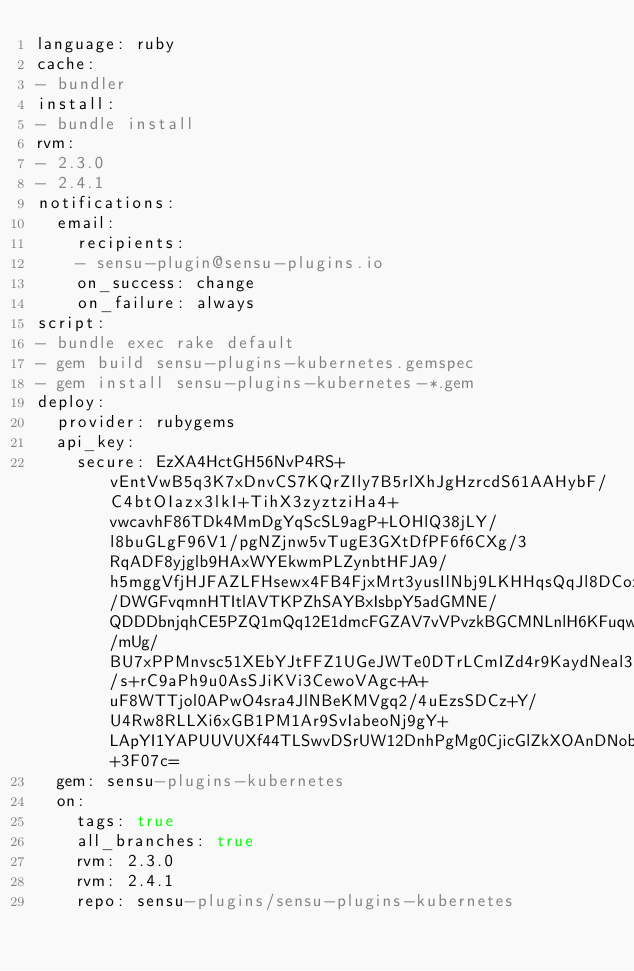<code> <loc_0><loc_0><loc_500><loc_500><_YAML_>language: ruby
cache:
- bundler
install:
- bundle install
rvm:
- 2.3.0
- 2.4.1
notifications:
  email:
    recipients:
    - sensu-plugin@sensu-plugins.io
    on_success: change
    on_failure: always
script:
- bundle exec rake default
- gem build sensu-plugins-kubernetes.gemspec
- gem install sensu-plugins-kubernetes-*.gem
deploy:
  provider: rubygems
  api_key:
    secure: EzXA4HctGH56NvP4RS+vEntVwB5q3K7xDnvCS7KQrZIly7B5rlXhJgHzrcdS61AAHybF/C4btOIazx3lkI+TihX3zyztziHa4+vwcavhF86TDk4MmDgYqScSL9agP+LOHlQ38jLY/l8buGLgF96V1/pgNZjnw5vTugE3GXtDfPF6f6CXg/3RqADF8yjglb9HAxWYEkwmPLZynbtHFJA9/h5mggVfjHJFAZLFHsewx4FB4FjxMrt3yusIlNbj9LKHHqsQqJl8DCoxGhiQmysSLS3NoN7vVhi3UA4TdHArtSZgRmsZKhsJDGcgM/DWGFvqmnHTItlAVTKPZhSAYBxIsbpY5adGMNE/QDDDbnjqhCE5PZQ1mQq12E1dmcFGZAV7vVPvzkBGCMNLnlH6KFuqw/mUg/BU7xPPMnvsc51XEbYJtFFZ1UGeJWTe0DTrLCmIZd4r9KaydNeal35iu/s+rC9aPh9u0AsSJiKVi3CewoVAgc+A+uF8WTTjol0APwO4sra4JlNBeKMVgq2/4uEzsSDCz+Y/U4Rw8RLLXi6xGB1PM1Ar9SvIabeoNj9gY+LApYI1YAPUUVUXf44TLSwvDSrUW12DnhPgMg0CjicGlZkXOAnDNob8b8bU8YUP7wN8eOwt0J63hhn40G7XCA5WCpNm0W7qbLlV8sUBb+3F07c=
  gem: sensu-plugins-kubernetes
  on:
    tags: true
    all_branches: true
    rvm: 2.3.0
    rvm: 2.4.1
    repo: sensu-plugins/sensu-plugins-kubernetes
</code> 